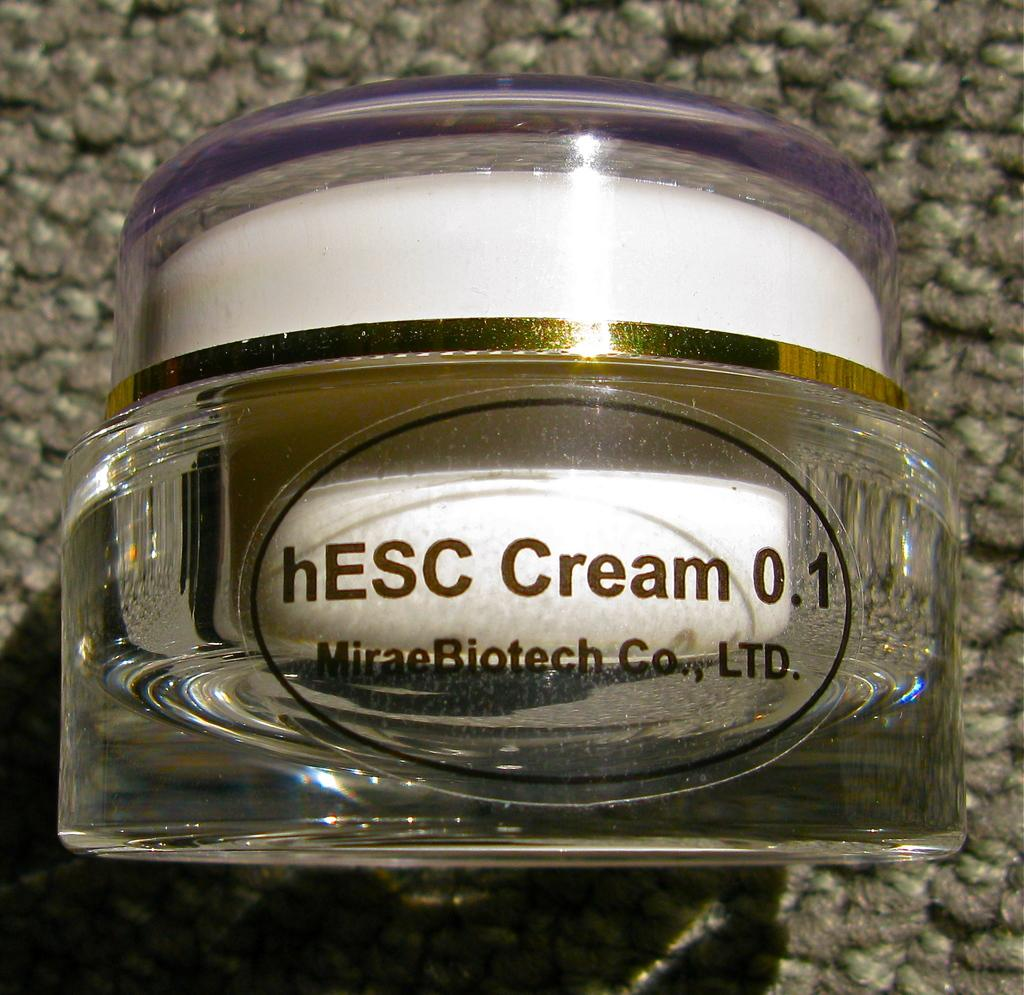What type of object is made of glass in the image? There is a glass object in the image. What is written or depicted on the glass object? There is text on the glass object. What is located at the bottom of the image? There is a mat at the bottom of the image. What type of treatment is being offered at the cemetery in the image? There is no cemetery present in the image, and therefore no treatment is being offered. 